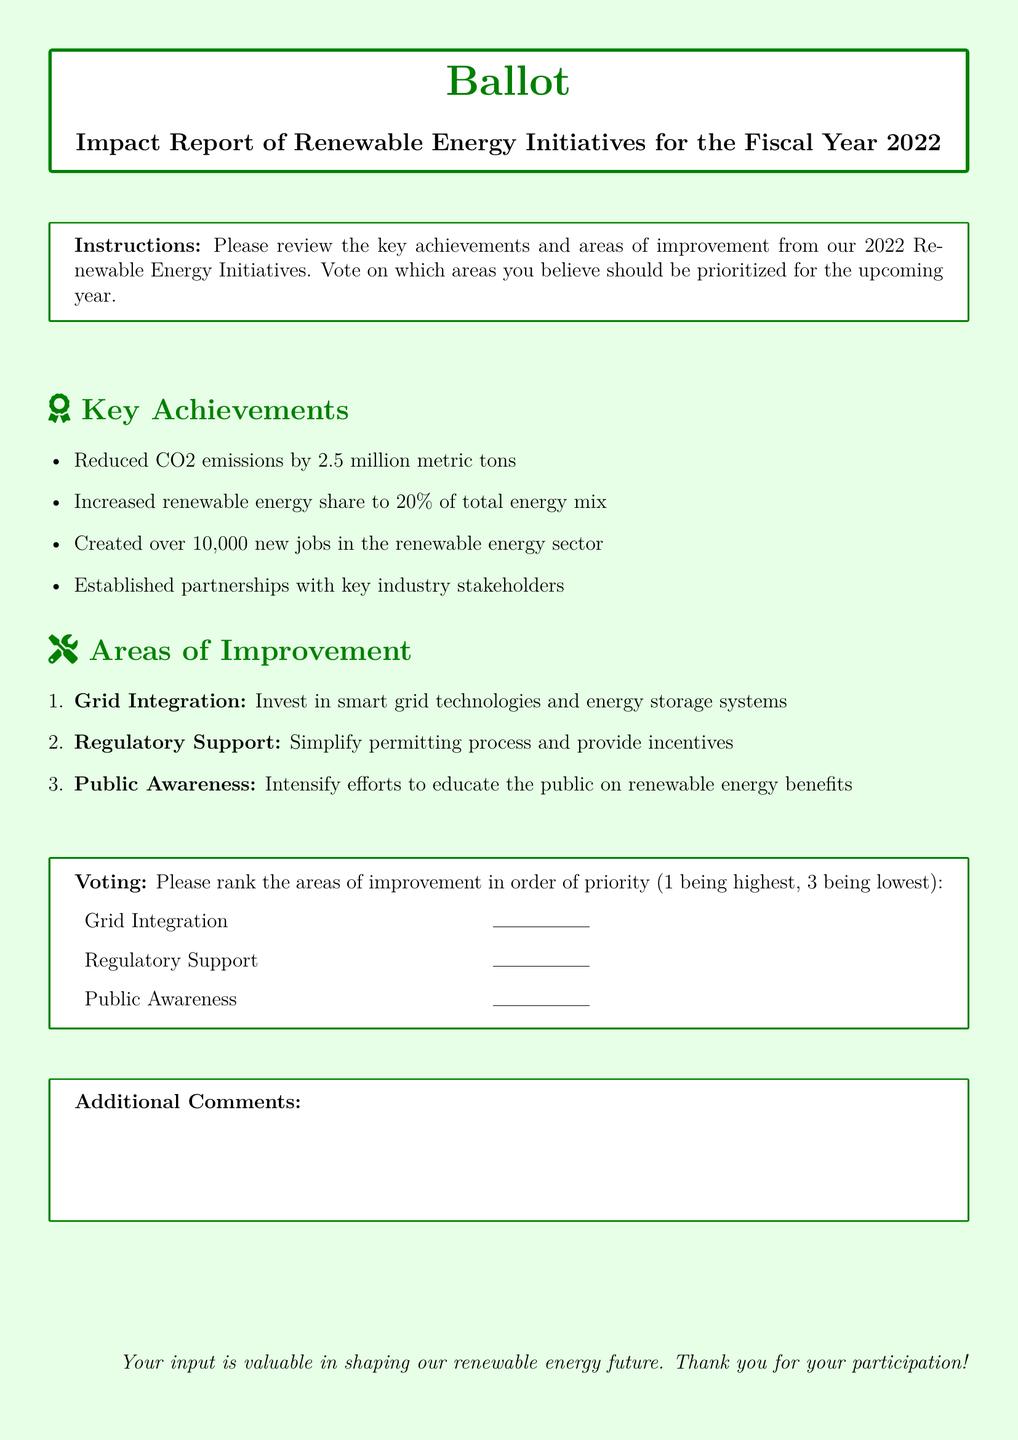What was the amount of CO2 emissions reduced? The document states that CO2 emissions were reduced by 2.5 million metric tons.
Answer: 2.5 million metric tons What percentage of the total energy mix is renewable energy? The document indicates that the renewable energy share increased to 20% of the total energy mix.
Answer: 20% How many new jobs were created in the renewable energy sector? The report mentions that over 10,000 new jobs were created in the renewable energy sector.
Answer: 10,000 What is one key area for improvement mentioned in the document? The document lists multiple areas for improvement; one is the investment in smart grid technologies and energy storage systems.
Answer: Grid Integration What voting method is suggested for prioritizing areas of improvement? The document instructs voters to rank the areas of improvement in order of priority followed by a number.
Answer: Ranking What is the overall context of this document? The document is a ballot regarding the impact report of renewable energy initiatives for the fiscal year 2022.
Answer: Impact report How many areas of improvement are listed in the document? The document enumerates three areas of improvement that need to be prioritized.
Answer: Three What does the document encourage readers to provide at the end? The document invites participants to provide additional comments at the end of the survey.
Answer: Additional comments 